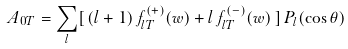<formula> <loc_0><loc_0><loc_500><loc_500>A _ { 0 T } = \sum _ { l } [ \, ( l + 1 ) \, f _ { l T } ^ { ( + ) } ( w ) + l \, f _ { l T } ^ { ( - ) } ( w ) \, ] \, P _ { l } ( \cos { \theta } )</formula> 